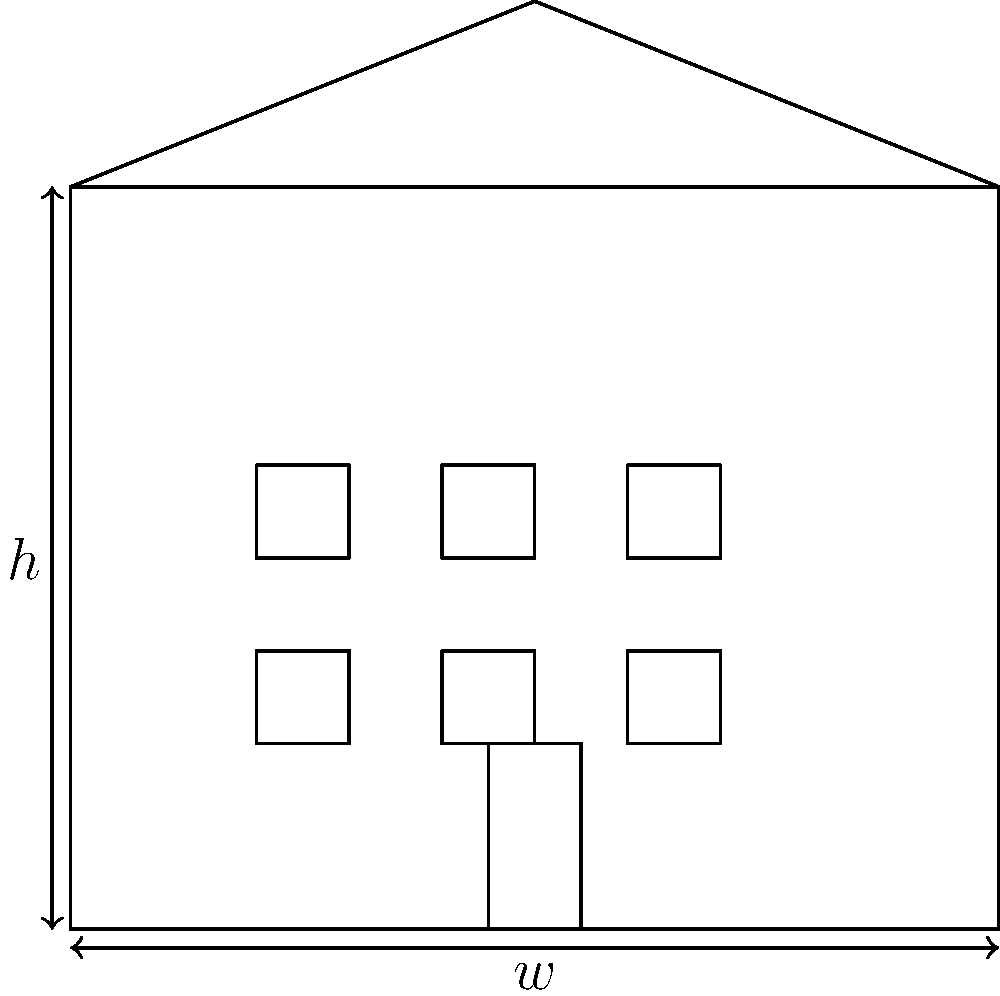Given the facade of the existing museum building shown above, with width $w$ and height $h$, determine the ratio of the facade's width to its height. How does this ratio relate to the golden ratio ($\phi \approx 1.618$), and what implications might this have for designing a harmonious expansion? To analyze the proportions and symmetry of the existing museum facade, we'll follow these steps:

1. Calculate the width-to-height ratio:
   The facade's width is $w$ and its height is $h$.
   Ratio = $\frac{w}{h}$

2. Compare to the golden ratio:
   The golden ratio, $\phi \approx 1.618$, is often considered aesthetically pleasing in architecture.

3. Analyze the facade:
   a) Symmetry: The facade appears symmetrical along the vertical axis.
   b) Window placement: 3 columns and 2 rows, creating a balanced grid.
   c) Entrance: Centrally located, reinforcing symmetry.
   d) Roof: Triangular shape adds visual interest and balance.

4. Implications for expansion design:
   a) If $\frac{w}{h} \approx \phi$, consider maintaining this ratio in the expansion for visual harmony.
   b) If $\frac{w}{h} \neq \phi$, decide whether to match the existing ratio or introduce the golden ratio in the new design.
   c) Maintain symmetry in the expansion to complement the existing facade.
   d) Consider replicating the window grid pattern and central entrance concept.
   e) The roof design could be echoed or contrasted in the expansion, depending on the desired effect.

5. Additional considerations:
   a) Materials: Choose materials that complement the existing structure.
   b) Height: Decide whether to match or contrast the current building's height.
   c) Style: Determine if the expansion should mimic the existing style or provide a contemporary contrast while maintaining proportional harmony.

By carefully analyzing these aspects, you can design an expansion that respects the existing building's proportions and symmetry while potentially introducing elements of the golden ratio for enhanced aesthetic appeal.
Answer: Analyze $\frac{w}{h}$ ratio, compare to $\phi$, maintain symmetry, consider window patterns and roof design in expansion. 